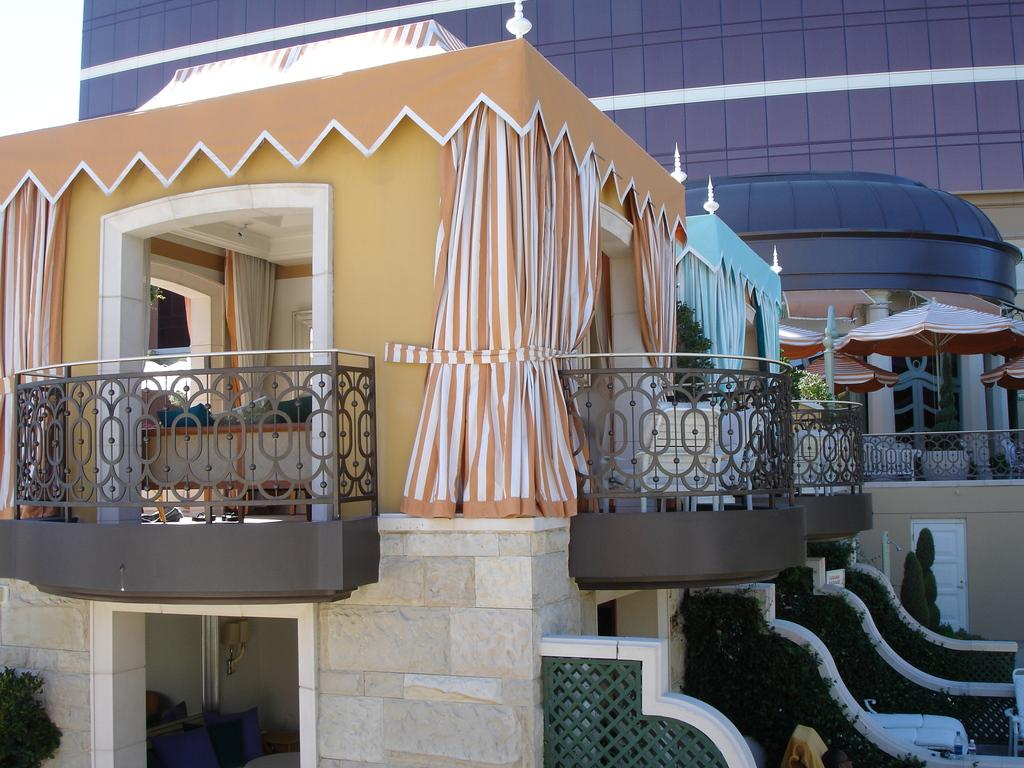What type of structures can be seen in the image? There are buildings in the image. What type of window treatment is present in the image? There are curtains in the image. What material is used for the rods in the image? Metal rods are present in the image. What type of vegetation is visible in the image? Plants are visible in the image. Where are the umbrellas located in the image? The umbrellas are on the right side of the image. What type of corn can be seen growing in the wilderness in the image? There is no corn or wilderness present in the image. What effect does the presence of the umbrellas have on the plants in the image? The presence of umbrellas does not have any effect on the plants in the image, as they are separate objects. 